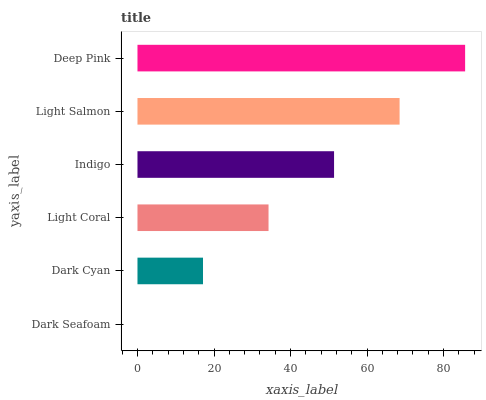Is Dark Seafoam the minimum?
Answer yes or no. Yes. Is Deep Pink the maximum?
Answer yes or no. Yes. Is Dark Cyan the minimum?
Answer yes or no. No. Is Dark Cyan the maximum?
Answer yes or no. No. Is Dark Cyan greater than Dark Seafoam?
Answer yes or no. Yes. Is Dark Seafoam less than Dark Cyan?
Answer yes or no. Yes. Is Dark Seafoam greater than Dark Cyan?
Answer yes or no. No. Is Dark Cyan less than Dark Seafoam?
Answer yes or no. No. Is Indigo the high median?
Answer yes or no. Yes. Is Light Coral the low median?
Answer yes or no. Yes. Is Light Salmon the high median?
Answer yes or no. No. Is Dark Cyan the low median?
Answer yes or no. No. 